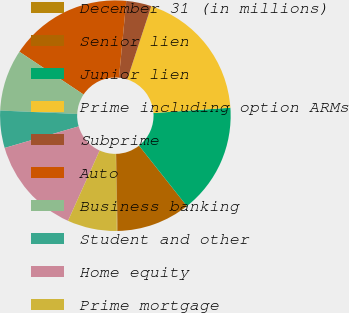<chart> <loc_0><loc_0><loc_500><loc_500><pie_chart><fcel>December 31 (in millions)<fcel>Senior lien<fcel>Junior lien<fcel>Prime including option ARMs<fcel>Subprime<fcel>Auto<fcel>Business banking<fcel>Student and other<fcel>Home equity<fcel>Prime mortgage<nl><fcel>0.12%<fcel>10.34%<fcel>15.45%<fcel>18.86%<fcel>3.53%<fcel>17.16%<fcel>8.64%<fcel>5.23%<fcel>13.75%<fcel>6.93%<nl></chart> 